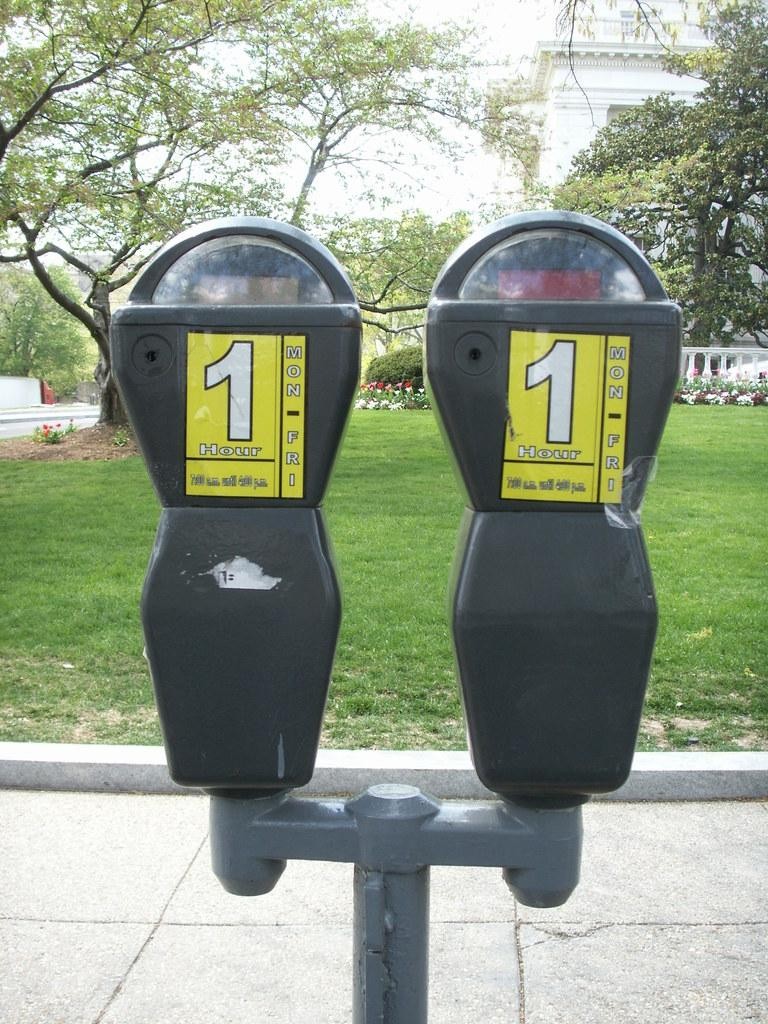<image>
Share a concise interpretation of the image provided. Outside, in front of a sidewalk and a field of grass are two parking meters, side by side, both with yellow signs enforcing 1 hour parking. 